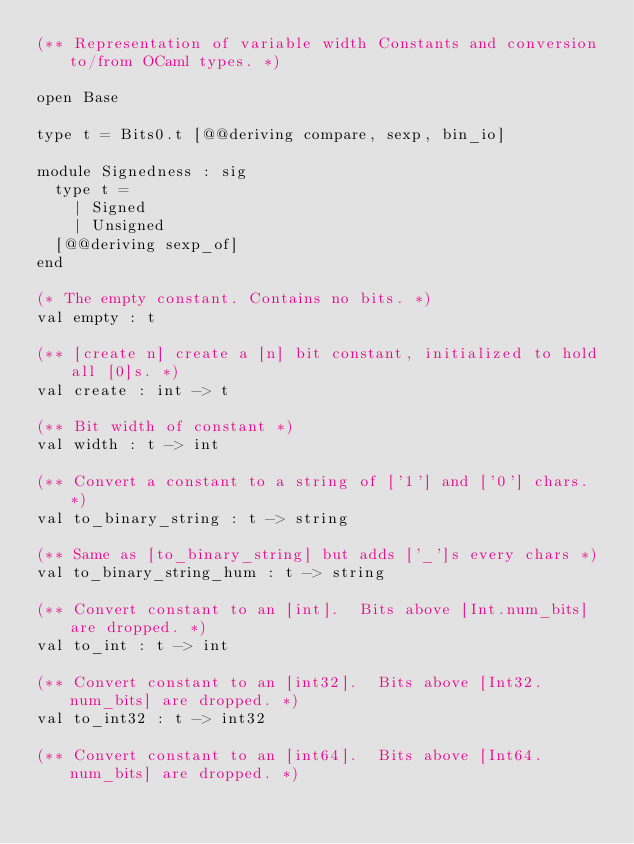<code> <loc_0><loc_0><loc_500><loc_500><_OCaml_>(** Representation of variable width Constants and conversion to/from OCaml types. *)

open Base

type t = Bits0.t [@@deriving compare, sexp, bin_io]

module Signedness : sig
  type t =
    | Signed
    | Unsigned
  [@@deriving sexp_of]
end

(* The empty constant. Contains no bits. *)
val empty : t

(** [create n] create a [n] bit constant, initialized to hold all [0]s. *)
val create : int -> t

(** Bit width of constant *)
val width : t -> int

(** Convert a constant to a string of ['1'] and ['0'] chars. *)
val to_binary_string : t -> string

(** Same as [to_binary_string] but adds ['_']s every chars *)
val to_binary_string_hum : t -> string

(** Convert constant to an [int].  Bits above [Int.num_bits] are dropped. *)
val to_int : t -> int

(** Convert constant to an [int32].  Bits above [Int32.num_bits] are dropped. *)
val to_int32 : t -> int32

(** Convert constant to an [int64].  Bits above [Int64.num_bits] are dropped. *)</code> 